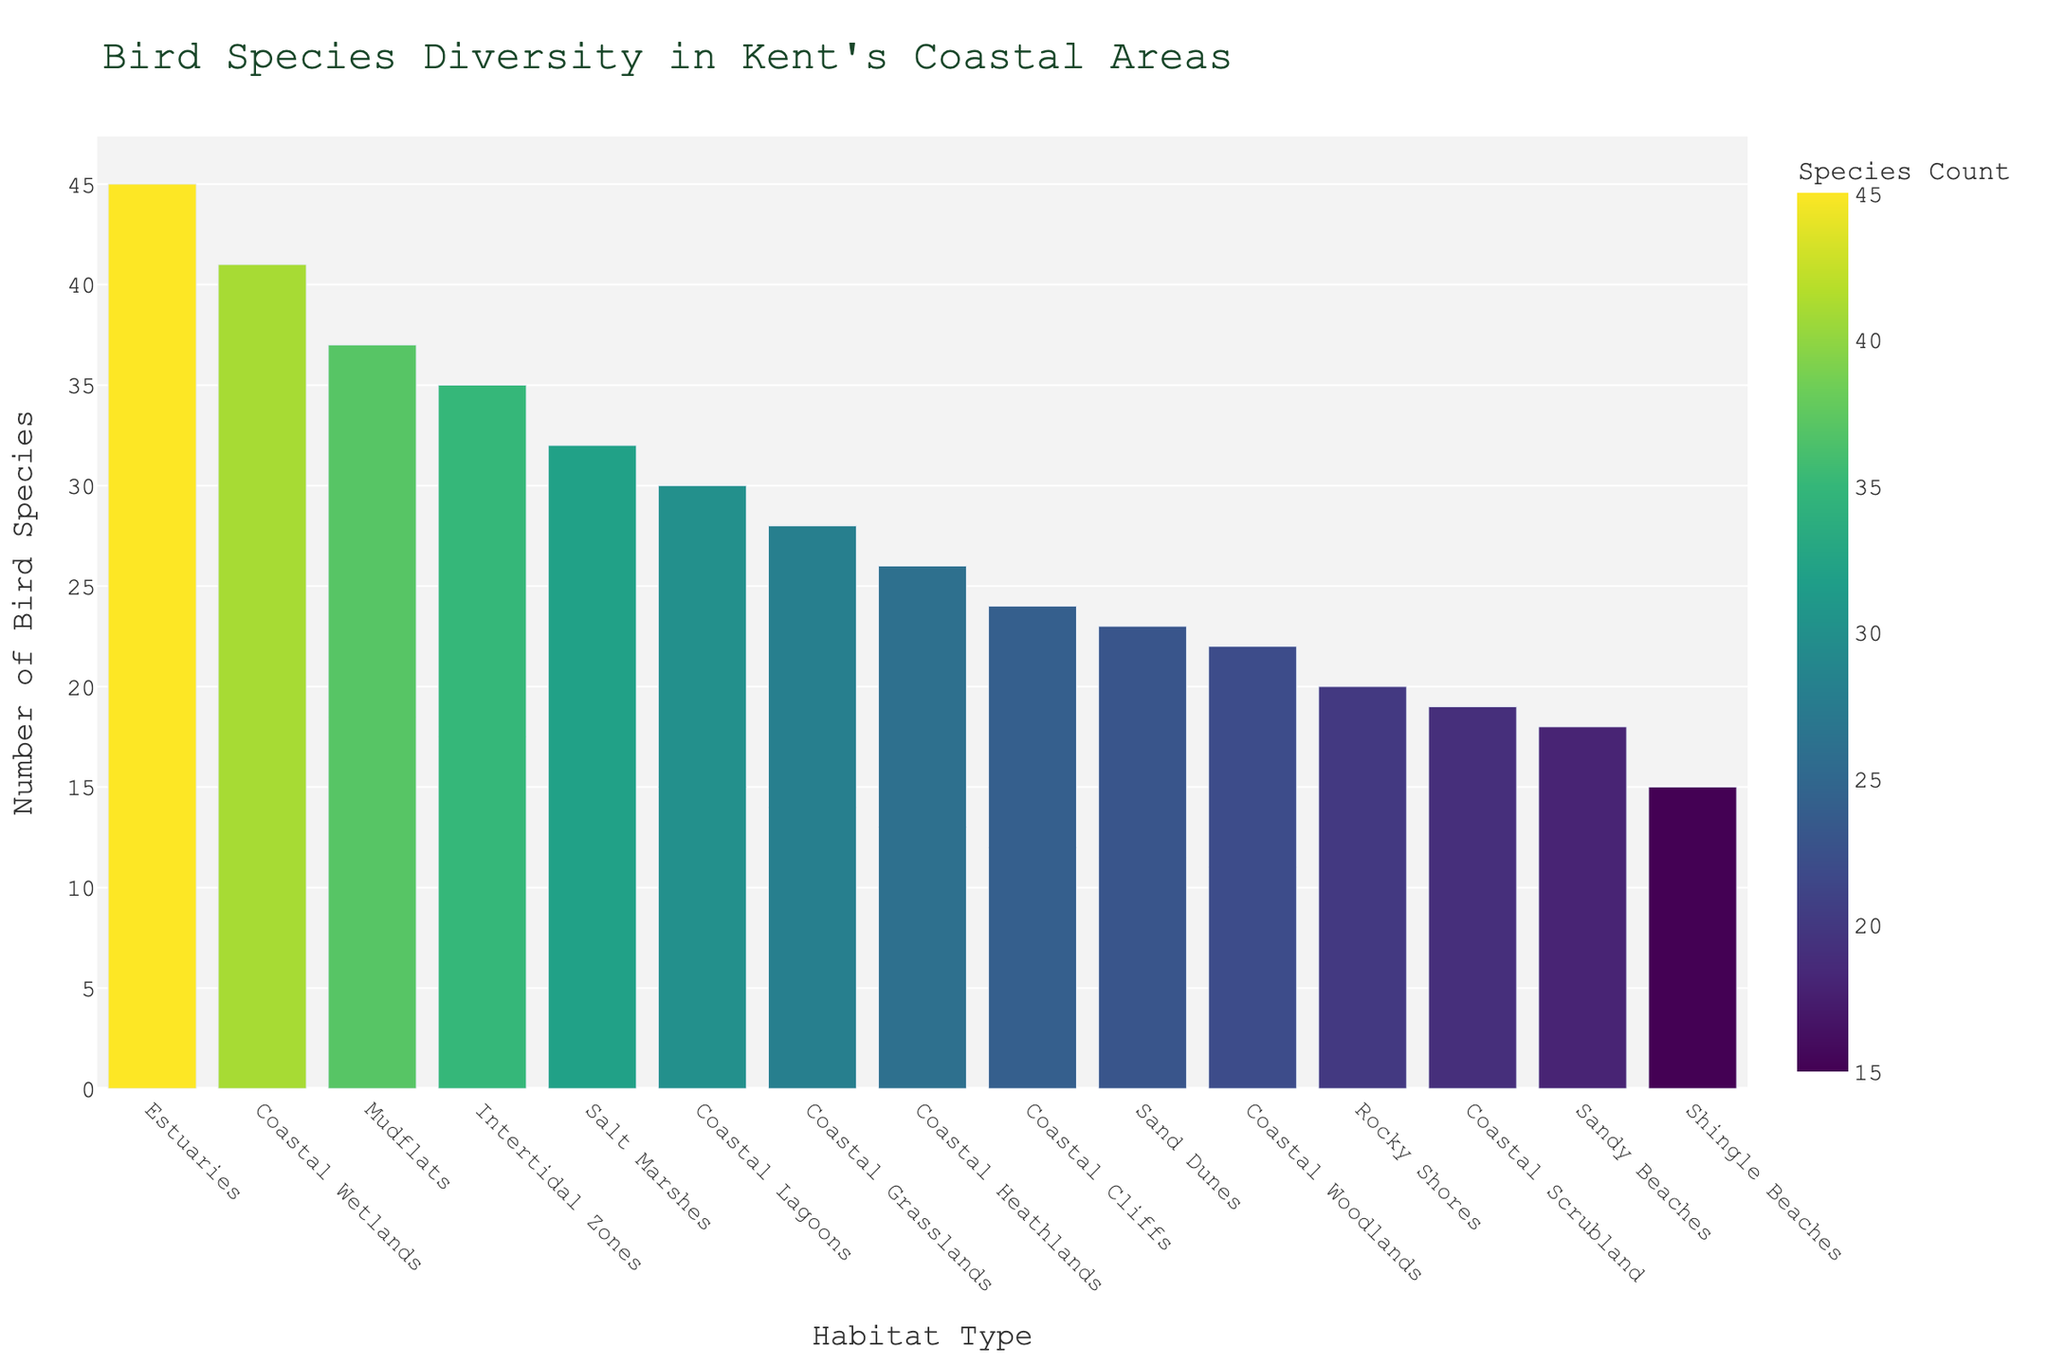What habitat type has the highest number of bird species? By looking at the height of the bars, the tallest bar corresponds to the habitat 'Estuaries'.
Answer: Estuaries What is the total number of bird species counted in Sandy Beaches and Coastal Cliffs? Add the counts of Sandy Beaches (18) and Coastal Cliffs (24). The total is 18 + 24 = 42.
Answer: 42 How many more bird species are there in Coastal Woodlands compared to Shingle Beaches? Subtract the count of Shingle Beaches (15) from Coastal Woodlands (22). The difference is 22 - 15 = 7.
Answer: 7 Which habitat has more bird species, Coastal Grasslands or Coastal Lagoons? Compare the heights of the bars for Coastal Grasslands (28) and Coastal Lagoons (30). Coastal Lagoons has a higher count.
Answer: Coastal Lagoons What habitat type has the smallest number of bird species? By looking at the height of the bars, the shortest bar corresponds to 'Shingle Beaches'.
Answer: Shingle Beaches What is the average number of bird species across all habitats? Sum the bird species counts for all habitats (391), then divide by the number of habitat types (15). The average is 391 / 15 ≈ 26.07.
Answer: 26.07 How many habitats have a bird species count greater than 30? Count the number of bars with a height that corresponds to a bird species count greater than 30: Salt Marshes, Mudflats, Intertidal Zones, Estuaries, Coastal Wetlands (5 habitats).
Answer: 5 What is the difference between the bird species counts of Coastal Wetlands and Coastal Heathlands? Subtract the count of Coastal Heathlands (26) from Coastal Wetlands (41). The difference is 41 - 26 = 15.
Answer: 15 Which habitat types have bird species counts close to the median count? Arrange the counts in ascending order and find the middle values. The median bird species count is approximate for Coastal Heathlands (26), Coastal Grasslands (28), and Coastal Lagoons (30).
Answer: Coastal Heathlands, Coastal Grasslands, Coastal Lagoons Is the bird species diversity higher in Sandy Beaches or in Intertidal Zones? Compare the counts for Sandy Beaches (18) and Intertidal Zones (35). Intertidal Zones have a higher count.
Answer: Intertidal Zones 